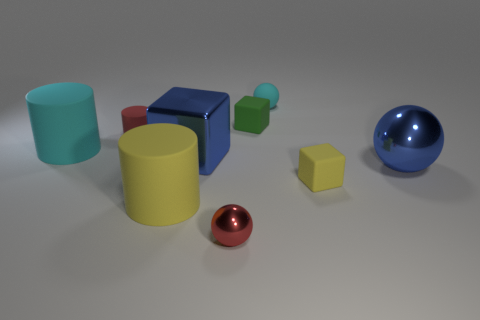Add 1 green objects. How many objects exist? 10 Subtract all cylinders. How many objects are left? 6 Add 9 small red metal objects. How many small red metal objects exist? 10 Subtract 0 yellow spheres. How many objects are left? 9 Subtract all matte objects. Subtract all yellow rubber objects. How many objects are left? 1 Add 2 large balls. How many large balls are left? 3 